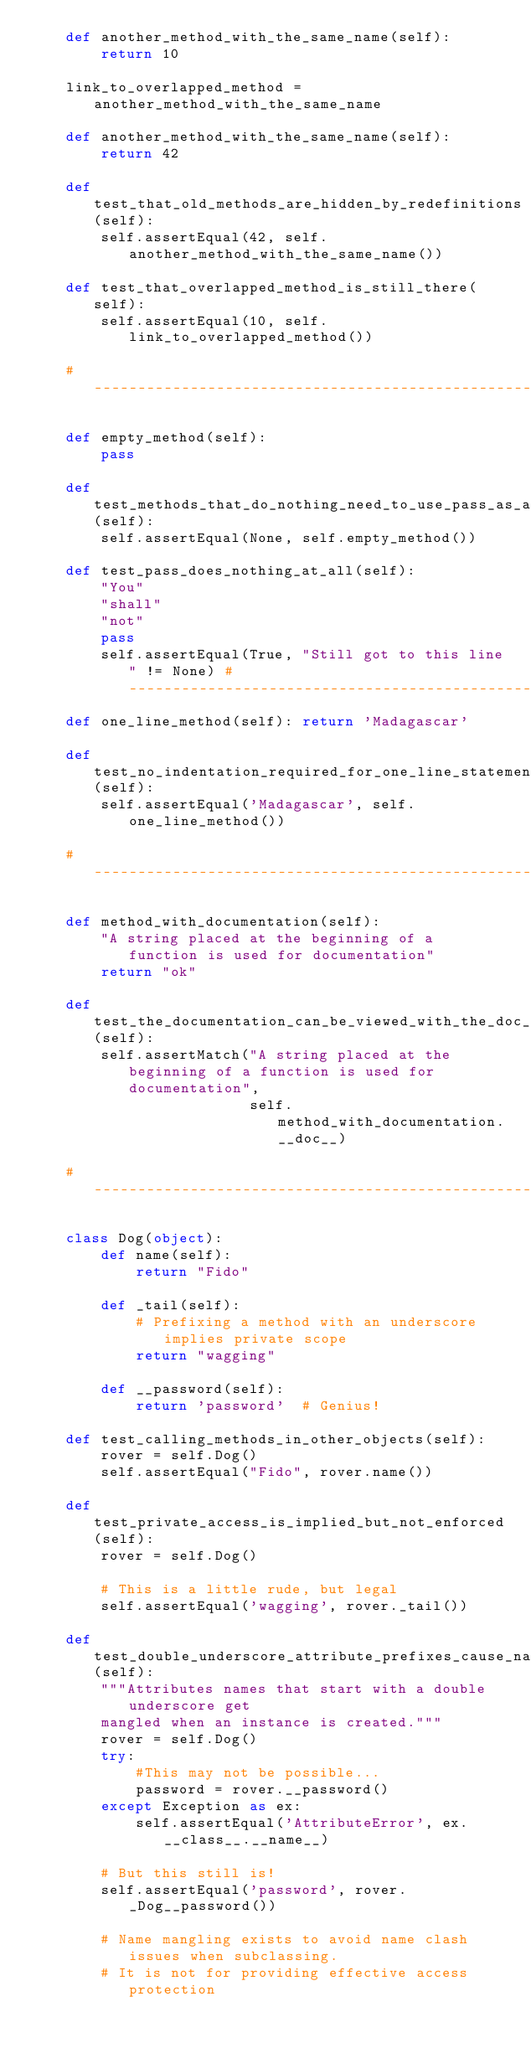<code> <loc_0><loc_0><loc_500><loc_500><_Python_>    def another_method_with_the_same_name(self):
        return 10

    link_to_overlapped_method = another_method_with_the_same_name

    def another_method_with_the_same_name(self):
        return 42

    def test_that_old_methods_are_hidden_by_redefinitions(self):
        self.assertEqual(42, self.another_method_with_the_same_name())

    def test_that_overlapped_method_is_still_there(self):
        self.assertEqual(10, self.link_to_overlapped_method())

    # ------------------------------------------------------------------

    def empty_method(self):
        pass

    def test_methods_that_do_nothing_need_to_use_pass_as_a_filler(self):
        self.assertEqual(None, self.empty_method())

    def test_pass_does_nothing_at_all(self):
        "You"
        "shall"
        "not"
        pass 
        self.assertEqual(True, "Still got to this line" != None) # ------------------------------------------------------------------ 
    def one_line_method(self): return 'Madagascar'

    def test_no_indentation_required_for_one_line_statement_bodies(self):
        self.assertEqual('Madagascar', self.one_line_method())

    # ------------------------------------------------------------------

    def method_with_documentation(self):
        "A string placed at the beginning of a function is used for documentation"
        return "ok"

    def test_the_documentation_can_be_viewed_with_the_doc_method(self):
        self.assertMatch("A string placed at the beginning of a function is used for documentation",
                         self.method_with_documentation.__doc__)

    # ------------------------------------------------------------------

    class Dog(object):
        def name(self):
            return "Fido"

        def _tail(self):
            # Prefixing a method with an underscore implies private scope
            return "wagging"

        def __password(self):
            return 'password'  # Genius!

    def test_calling_methods_in_other_objects(self):
        rover = self.Dog()
        self.assertEqual("Fido", rover.name())

    def test_private_access_is_implied_but_not_enforced(self):
        rover = self.Dog()

        # This is a little rude, but legal
        self.assertEqual('wagging', rover._tail())

    def test_double_underscore_attribute_prefixes_cause_name_mangling(self):
        """Attributes names that start with a double underscore get
        mangled when an instance is created."""
        rover = self.Dog()
        try:
            #This may not be possible...
            password = rover.__password()
        except Exception as ex:
            self.assertEqual('AttributeError', ex.__class__.__name__)

        # But this still is!
        self.assertEqual('password', rover._Dog__password())

        # Name mangling exists to avoid name clash issues when subclassing.
        # It is not for providing effective access protection
</code> 